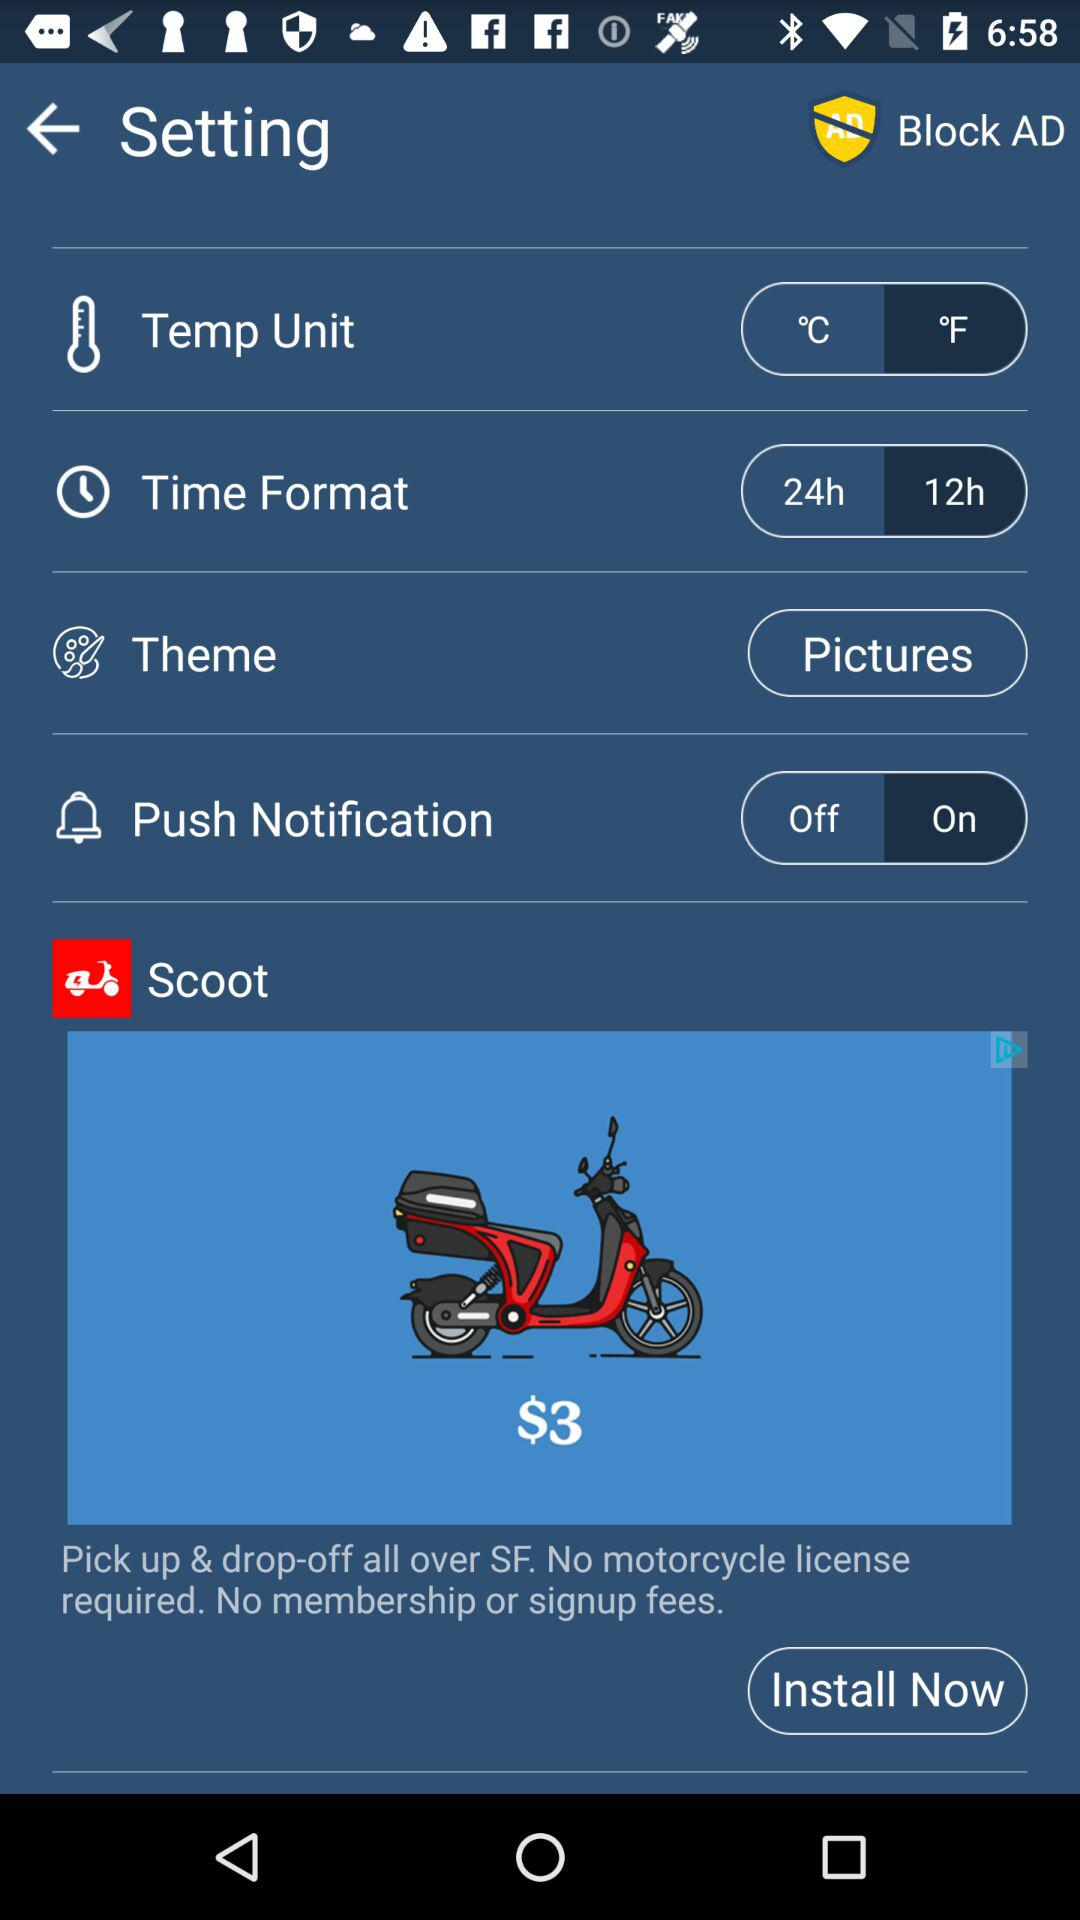What is the selected time format? The selected time format is "12h". 